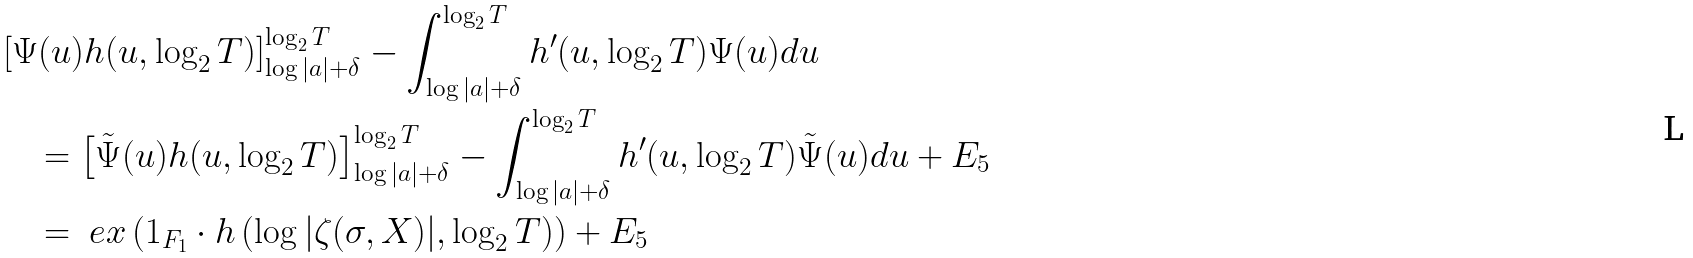Convert formula to latex. <formula><loc_0><loc_0><loc_500><loc_500>& \left [ \Psi ( u ) h ( u , \log _ { 2 } T ) \right ] _ { \log | a | + \delta } ^ { \log _ { 2 } T } - \int _ { \log | a | + \delta } ^ { \log _ { 2 } T } h ^ { \prime } ( u , \log _ { 2 } T ) \Psi ( u ) d u \\ & \quad = \left [ \tilde { \Psi } ( u ) h ( u , \log _ { 2 } T ) \right ] _ { \log | a | + \delta } ^ { \log _ { 2 } T } - \int _ { \log | a | + \delta } ^ { \log _ { 2 } T } h ^ { \prime } ( u , \log _ { 2 } T ) \tilde { \Psi } ( u ) d u + E _ { 5 } \\ & \quad = \ e x \left ( 1 _ { F _ { 1 } } \cdot h \left ( \log | \zeta ( \sigma , X ) | , \log _ { 2 } T \right ) \right ) + E _ { 5 }</formula> 